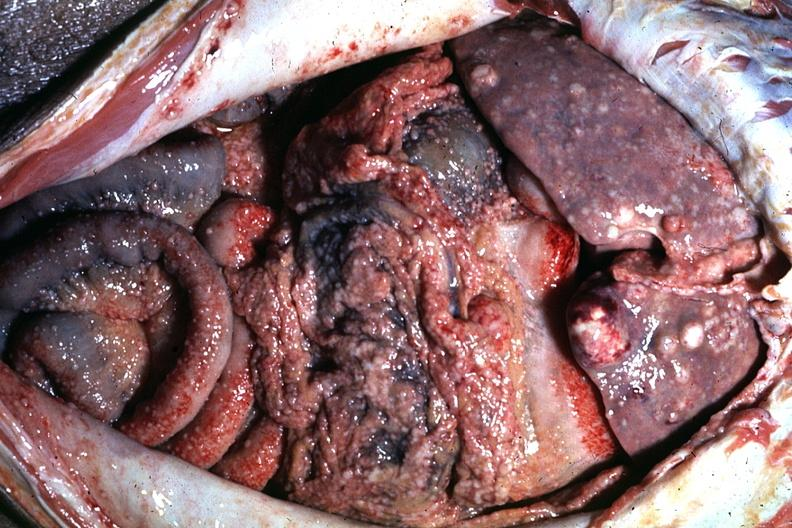does this image show excellent?
Answer the question using a single word or phrase. Yes 